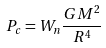<formula> <loc_0><loc_0><loc_500><loc_500>P _ { c } = W _ { n } \frac { G M ^ { 2 } } { R ^ { 4 } }</formula> 